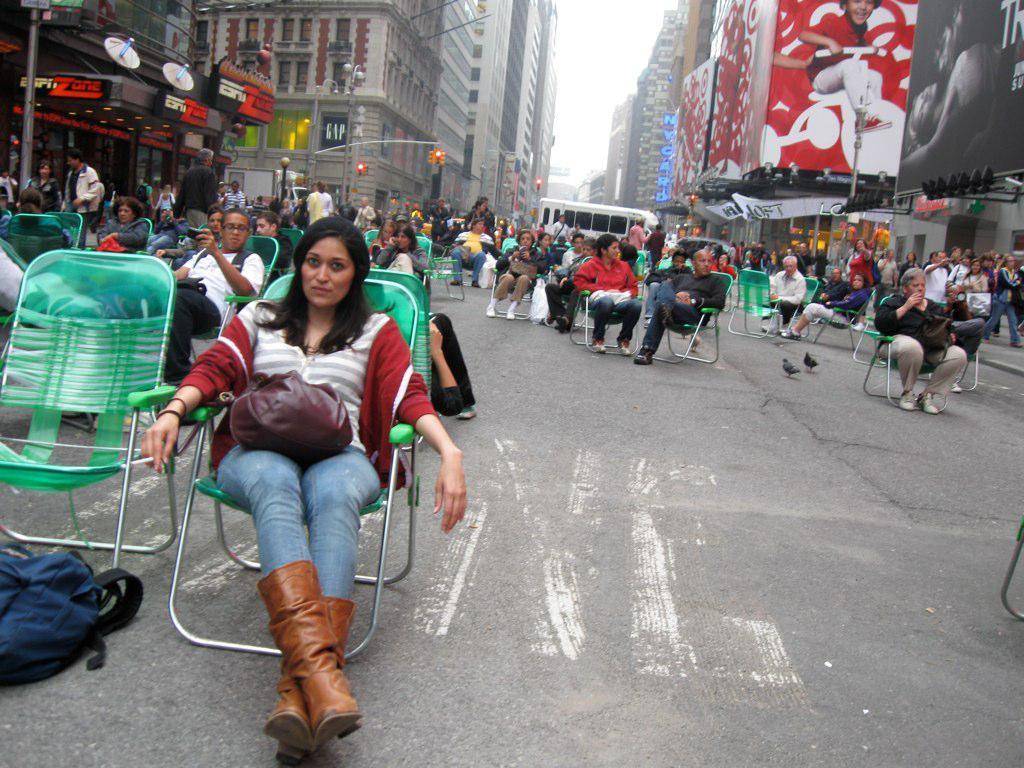Can you describe this image briefly? In this image we can see a group of people sitting on chairs placed on the road, a bag is placed on the ground. One person is holding a mobile in his hand. To the right side of the image we can see some people standing, the group of lights. To the left side of the image we can see a building with sign board with some text on it. In the background, we can see some traffic lights, poles, buildings with windows, a poster with a photo on it and the sky. 